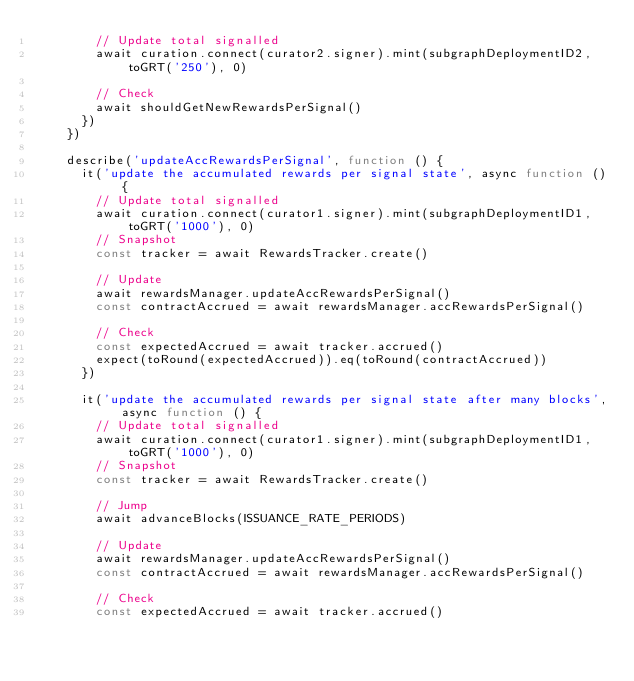Convert code to text. <code><loc_0><loc_0><loc_500><loc_500><_TypeScript_>        // Update total signalled
        await curation.connect(curator2.signer).mint(subgraphDeploymentID2, toGRT('250'), 0)

        // Check
        await shouldGetNewRewardsPerSignal()
      })
    })

    describe('updateAccRewardsPerSignal', function () {
      it('update the accumulated rewards per signal state', async function () {
        // Update total signalled
        await curation.connect(curator1.signer).mint(subgraphDeploymentID1, toGRT('1000'), 0)
        // Snapshot
        const tracker = await RewardsTracker.create()

        // Update
        await rewardsManager.updateAccRewardsPerSignal()
        const contractAccrued = await rewardsManager.accRewardsPerSignal()

        // Check
        const expectedAccrued = await tracker.accrued()
        expect(toRound(expectedAccrued)).eq(toRound(contractAccrued))
      })

      it('update the accumulated rewards per signal state after many blocks', async function () {
        // Update total signalled
        await curation.connect(curator1.signer).mint(subgraphDeploymentID1, toGRT('1000'), 0)
        // Snapshot
        const tracker = await RewardsTracker.create()

        // Jump
        await advanceBlocks(ISSUANCE_RATE_PERIODS)

        // Update
        await rewardsManager.updateAccRewardsPerSignal()
        const contractAccrued = await rewardsManager.accRewardsPerSignal()

        // Check
        const expectedAccrued = await tracker.accrued()</code> 